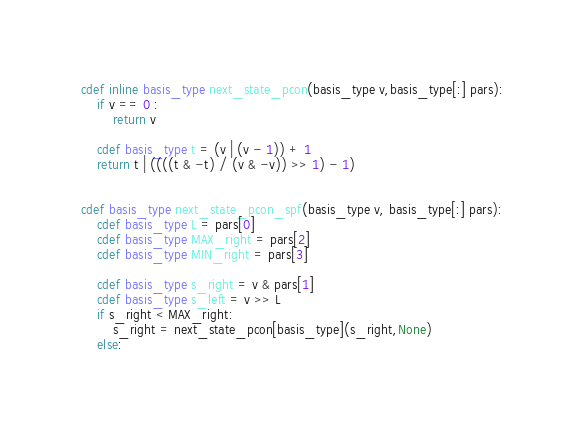<code> <loc_0><loc_0><loc_500><loc_500><_Cython_>cdef inline basis_type next_state_pcon(basis_type v,basis_type[:] pars):
	if v == 0 :
		return v

	cdef basis_type t = (v | (v - 1)) + 1
	return t | ((((t & -t) / (v & -v)) >> 1) - 1)


cdef basis_type next_state_pcon_spf(basis_type v, basis_type[:] pars):
	cdef basis_type L = pars[0]
	cdef basis_type MAX_right = pars[2]
	cdef basis_type MIN_right = pars[3]

	cdef basis_type s_right = v & pars[1]
	cdef basis_type s_left = v >> L
	if s_right < MAX_right:
		s_right = next_state_pcon[basis_type](s_right,None)
	else:</code> 